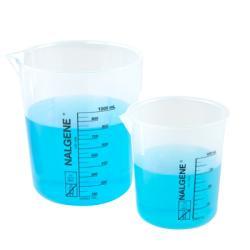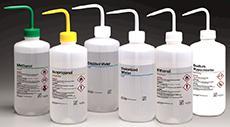The first image is the image on the left, the second image is the image on the right. Considering the images on both sides, is "The left image shows blue liquid in two containers, and the right image includes multiple capped bottles containing liquid." valid? Answer yes or no. Yes. The first image is the image on the left, the second image is the image on the right. Given the left and right images, does the statement "There are empty beakers." hold true? Answer yes or no. No. 